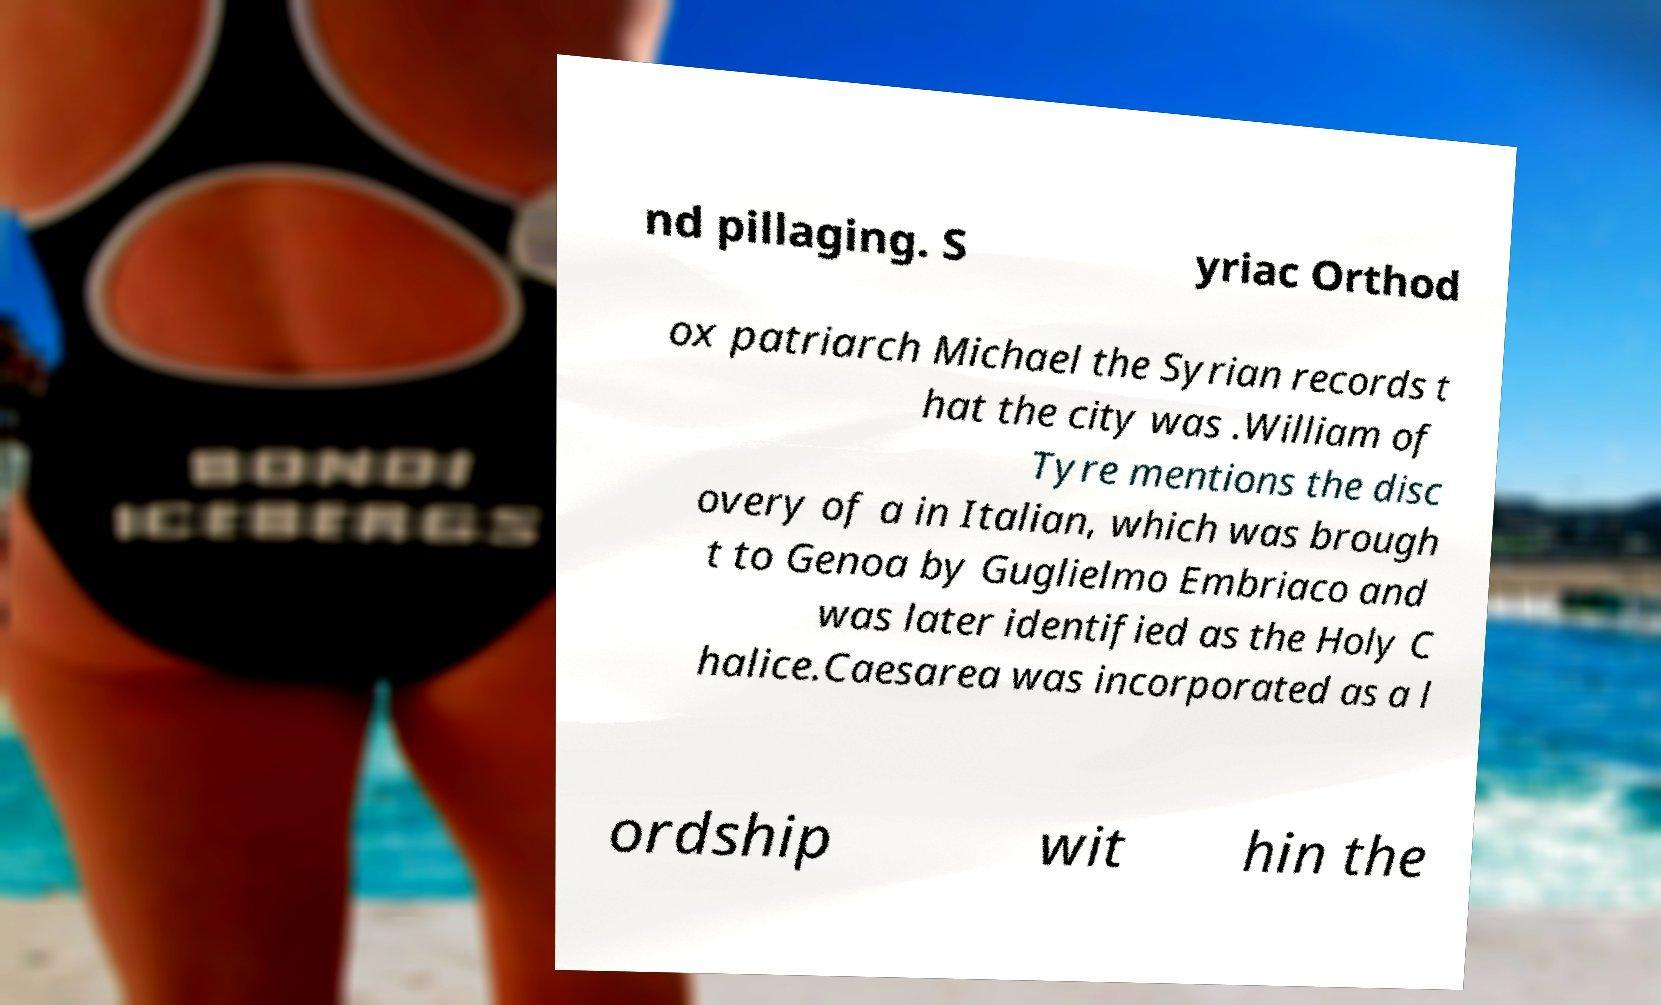Can you accurately transcribe the text from the provided image for me? nd pillaging. S yriac Orthod ox patriarch Michael the Syrian records t hat the city was .William of Tyre mentions the disc overy of a in Italian, which was brough t to Genoa by Guglielmo Embriaco and was later identified as the Holy C halice.Caesarea was incorporated as a l ordship wit hin the 